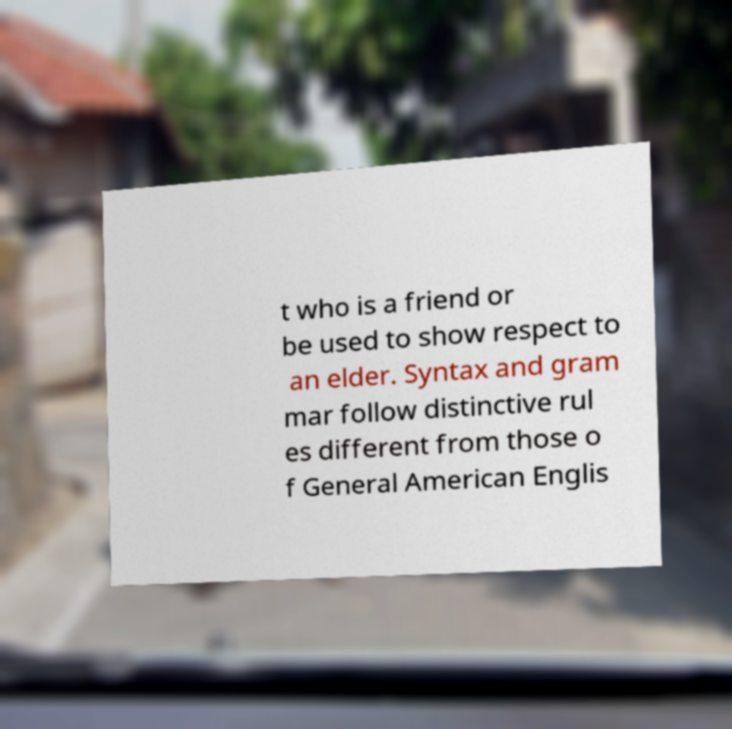There's text embedded in this image that I need extracted. Can you transcribe it verbatim? t who is a friend or be used to show respect to an elder. Syntax and gram mar follow distinctive rul es different from those o f General American Englis 